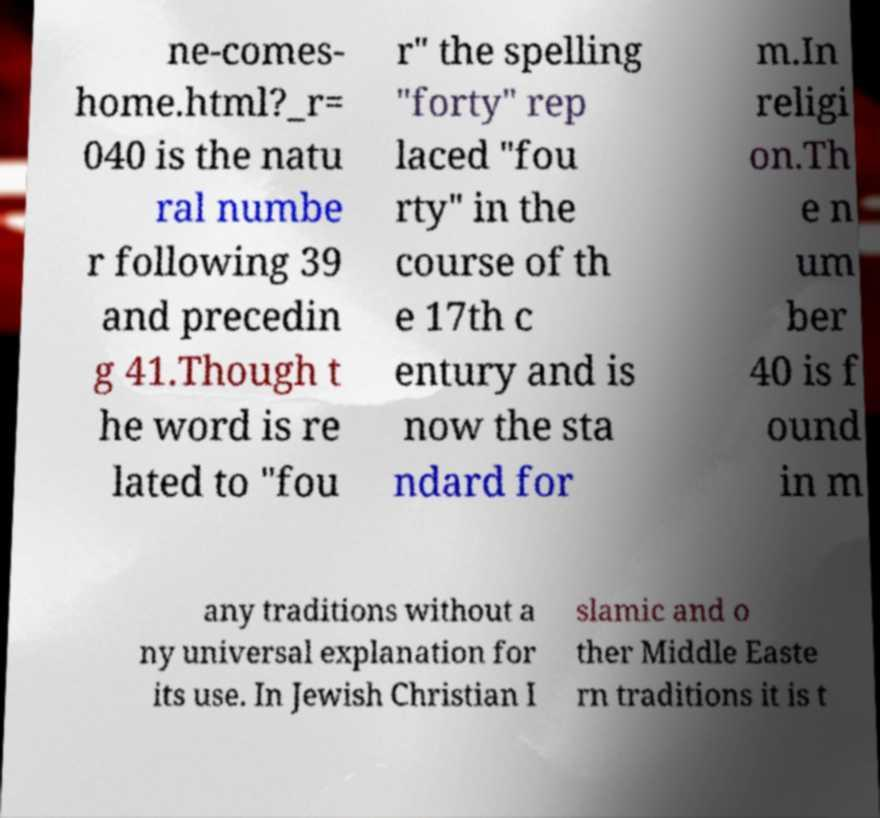Please read and relay the text visible in this image. What does it say? ne-comes- home.html?_r= 040 is the natu ral numbe r following 39 and precedin g 41.Though t he word is re lated to "fou r" the spelling "forty" rep laced "fou rty" in the course of th e 17th c entury and is now the sta ndard for m.In religi on.Th e n um ber 40 is f ound in m any traditions without a ny universal explanation for its use. In Jewish Christian I slamic and o ther Middle Easte rn traditions it is t 